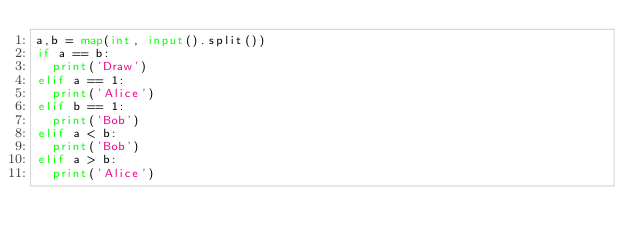<code> <loc_0><loc_0><loc_500><loc_500><_Python_>a,b = map(int, input().split())
if a == b:
  print('Draw')
elif a == 1:
  print('Alice')
elif b == 1:
  print('Bob')
elif a < b:
  print('Bob')
elif a > b:
  print('Alice')
</code> 